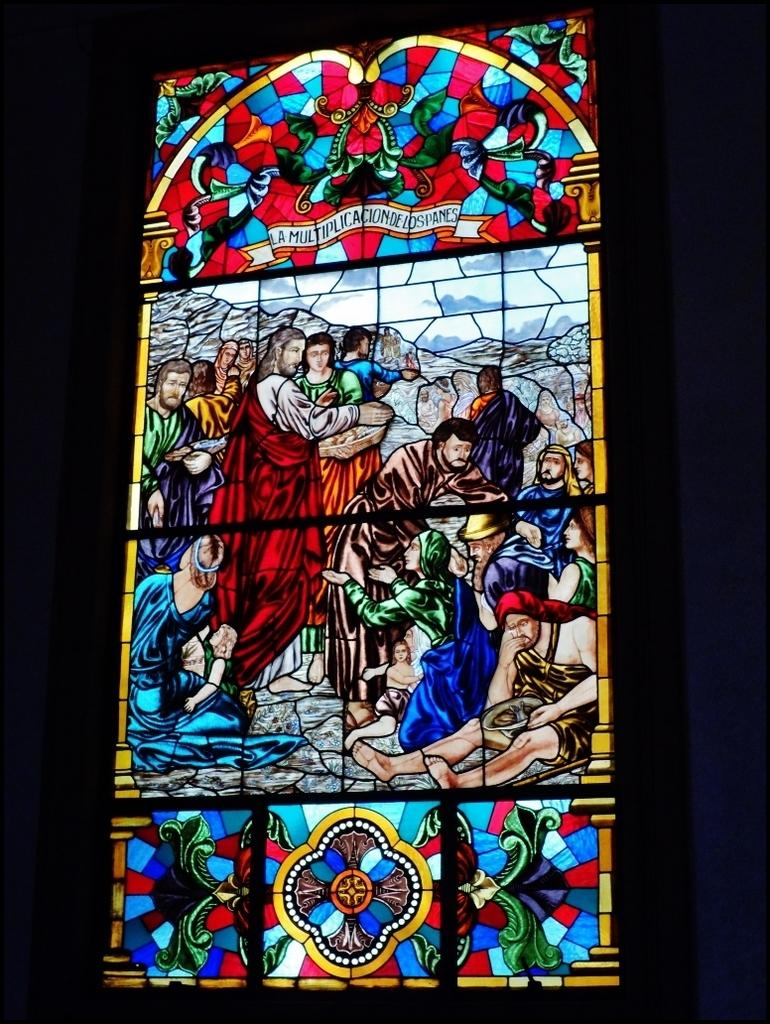What type of glass is featured in the image? There is stained glass in the image. What is depicted on the stained glass? The stained glass contains pictures of people. What is the color of the background in the image? The background of the image is dark. Can you tell me the direction the boat is sailing in the image? There is no boat present in the image; it features stained glass with pictures of people. What color is the wrist of the person depicted in the stained glass? The wrist of the person depicted in the stained glass cannot be determined from the image, as it is not visible. 